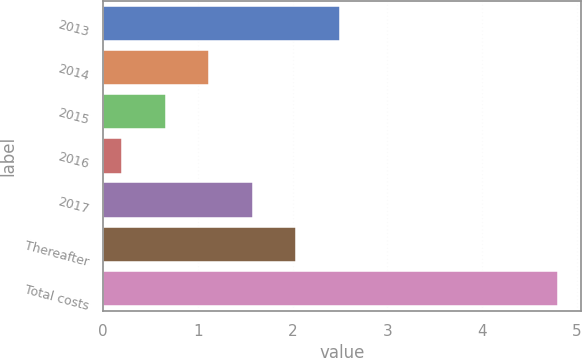<chart> <loc_0><loc_0><loc_500><loc_500><bar_chart><fcel>2013<fcel>2014<fcel>2015<fcel>2016<fcel>2017<fcel>Thereafter<fcel>Total costs<nl><fcel>2.5<fcel>1.12<fcel>0.66<fcel>0.2<fcel>1.58<fcel>2.04<fcel>4.8<nl></chart> 